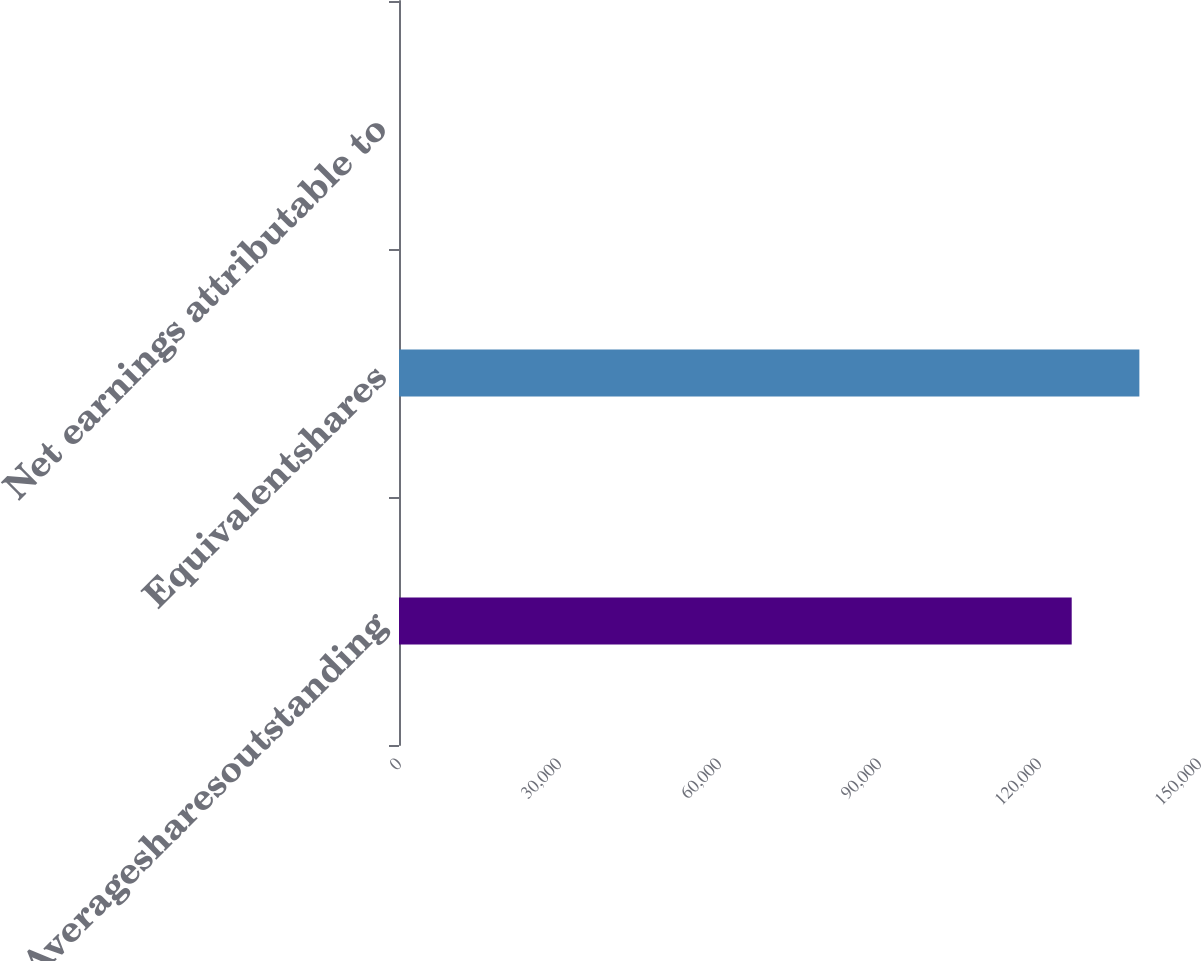<chart> <loc_0><loc_0><loc_500><loc_500><bar_chart><fcel>Averagesharesoutstanding<fcel>Equivalentshares<fcel>Net earnings attributable to<nl><fcel>126132<fcel>138821<fcel>1.74<nl></chart> 